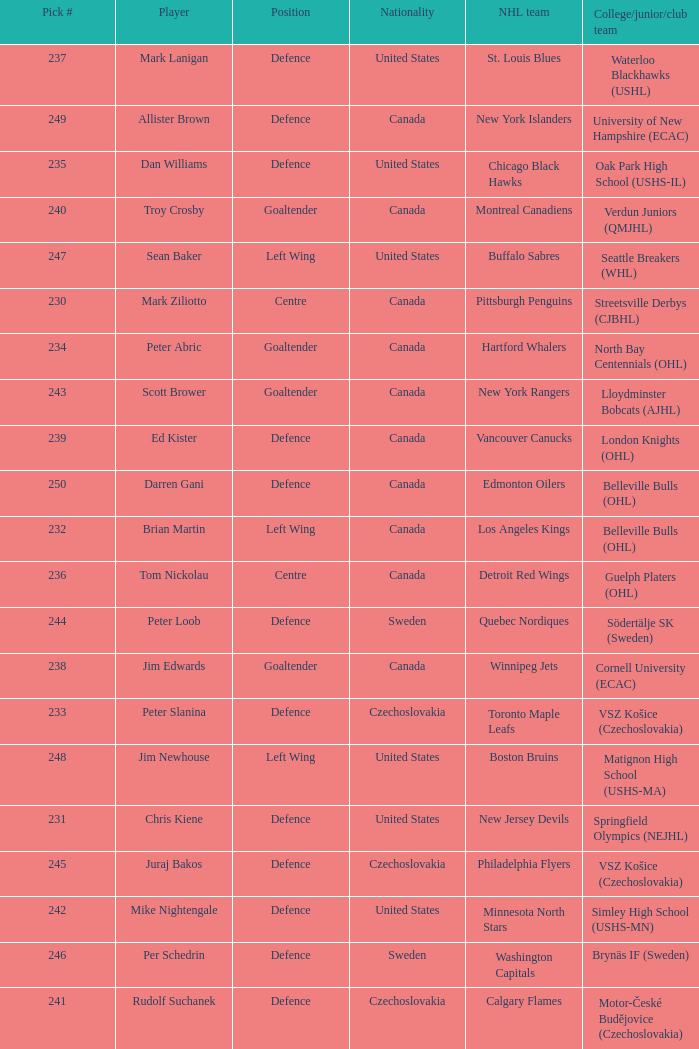To which organziation does the  winnipeg jets belong to? Cornell University (ECAC). 